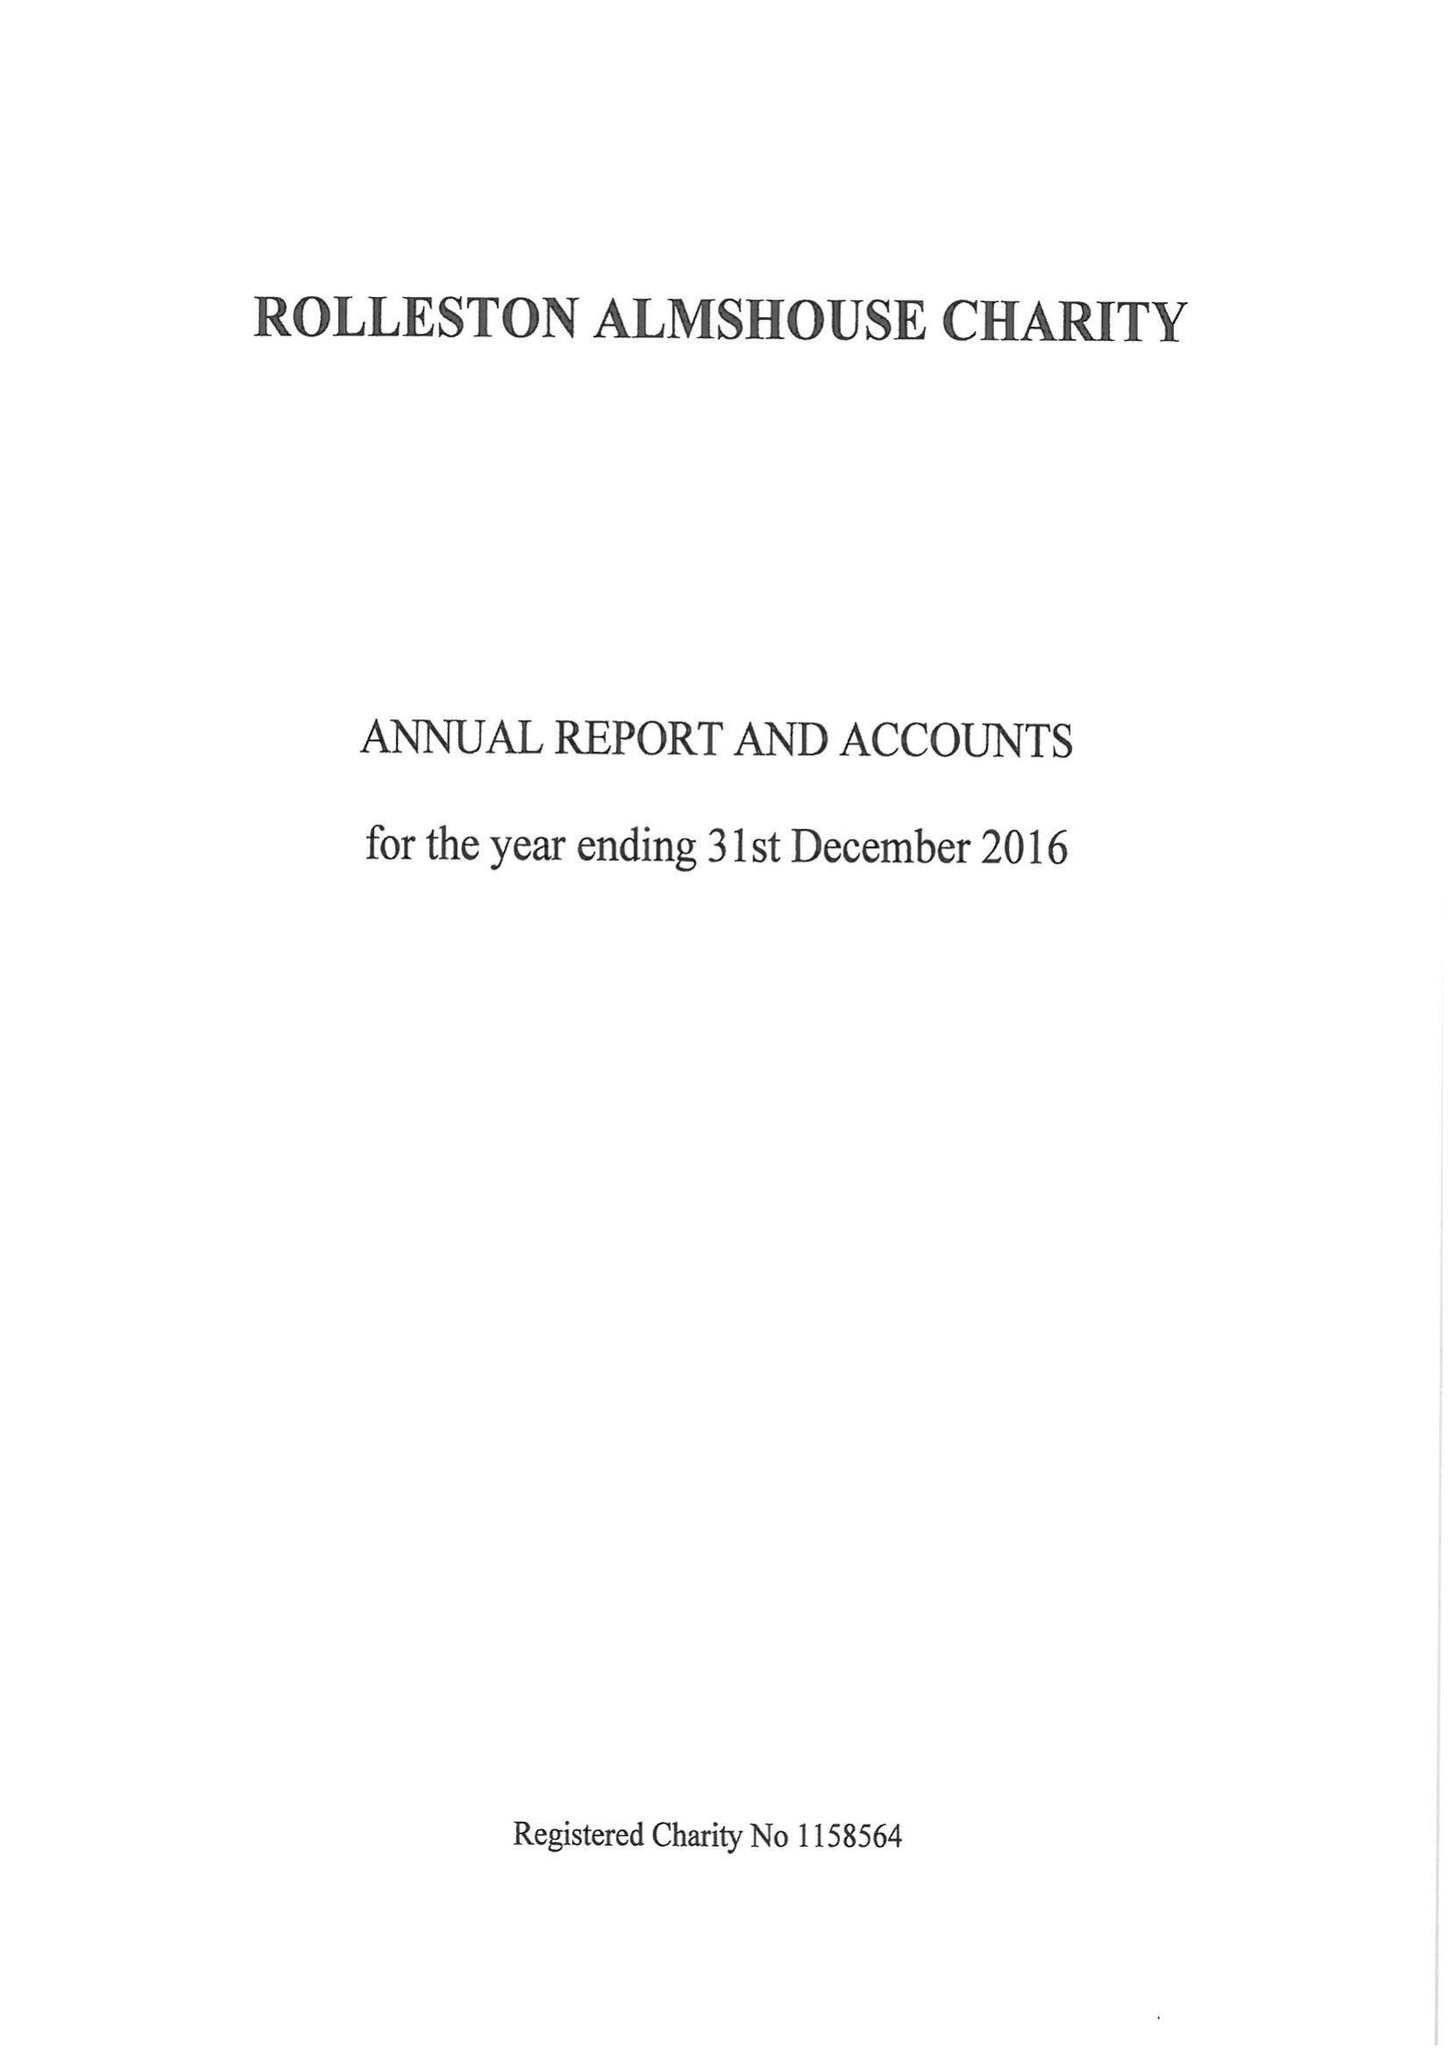What is the value for the income_annually_in_british_pounds?
Answer the question using a single word or phrase. 25327.00 